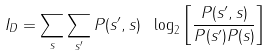<formula> <loc_0><loc_0><loc_500><loc_500>I _ { D } = \sum _ { s } \sum _ { s ^ { \prime } } P ( s ^ { \prime } , s ) \ \log _ { 2 } \left [ \frac { P ( s ^ { \prime } , s ) } { P ( s ^ { \prime } ) P ( s ) } \right ]</formula> 